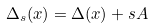<formula> <loc_0><loc_0><loc_500><loc_500>\Delta _ { s } ( x ) = \Delta ( x ) + s A</formula> 